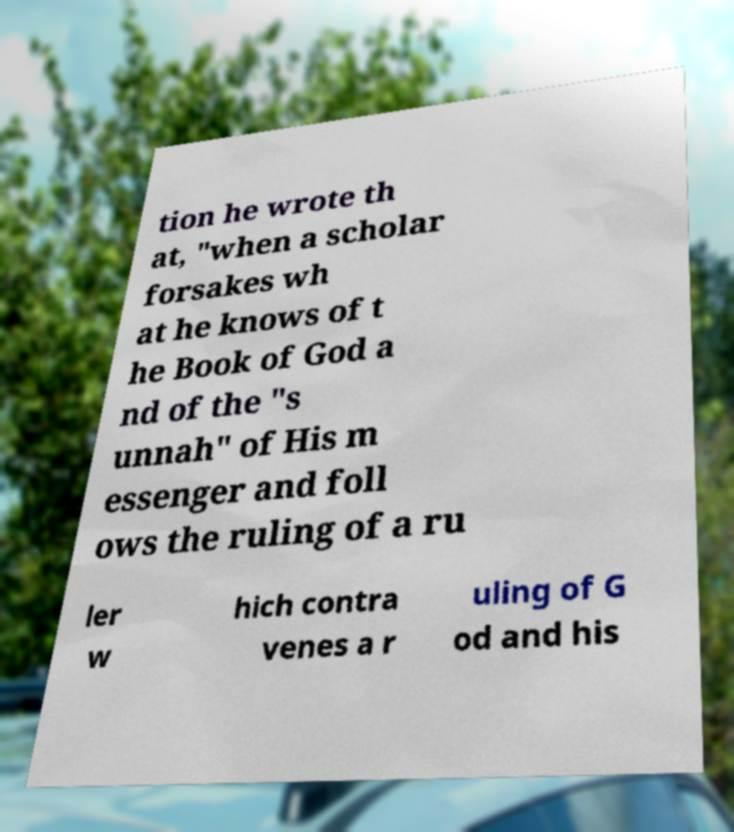Can you accurately transcribe the text from the provided image for me? tion he wrote th at, "when a scholar forsakes wh at he knows of t he Book of God a nd of the "s unnah" of His m essenger and foll ows the ruling of a ru ler w hich contra venes a r uling of G od and his 